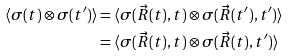<formula> <loc_0><loc_0><loc_500><loc_500>\langle \sigma ( t ) \otimes \sigma ( t ^ { \prime } ) \rangle & = \langle \sigma ( \vec { R } ( t ) , t ) \otimes \sigma ( \vec { R } ( t ^ { \prime } ) , t ^ { \prime } ) \rangle \\ & = \langle \sigma ( \vec { R } ( t ) , t ) \otimes \sigma ( \vec { R } ( t ) , t ^ { \prime } ) \rangle</formula> 